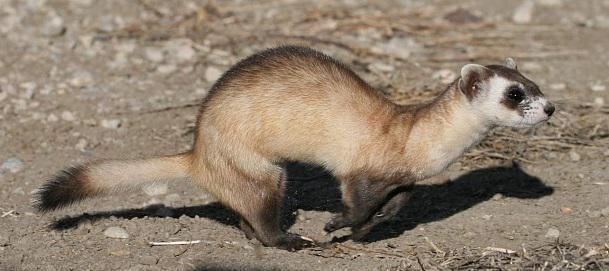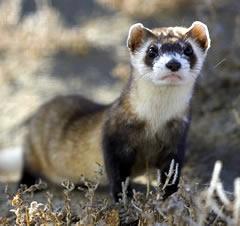The first image is the image on the left, the second image is the image on the right. Considering the images on both sides, is "ferrets are laying down and facing the camera" valid? Answer yes or no. No. The first image is the image on the left, the second image is the image on the right. Considering the images on both sides, is "In one of the images, the weasel's body is turned to the right, and in the other, it's turned to the left." valid? Answer yes or no. No. 